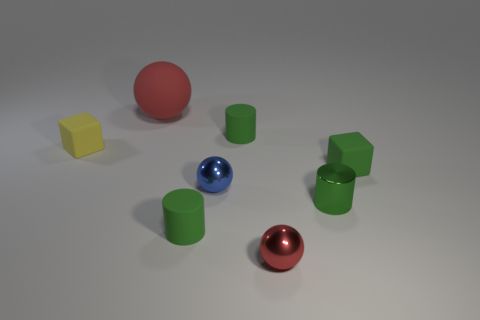Can you describe the material and color characteristics of the objects in the image? Certainly! There are objects with different materials and colors present. There's a large red rubber sphere with a shiny texture. Next, there are two matte cylinders, both in a shade of green, and a shiny blue sphere. In addition, there are two cubes – one is yellow and has a matte finish, and the other cube appears to be green and shiny, similar in material to the red sphere. 